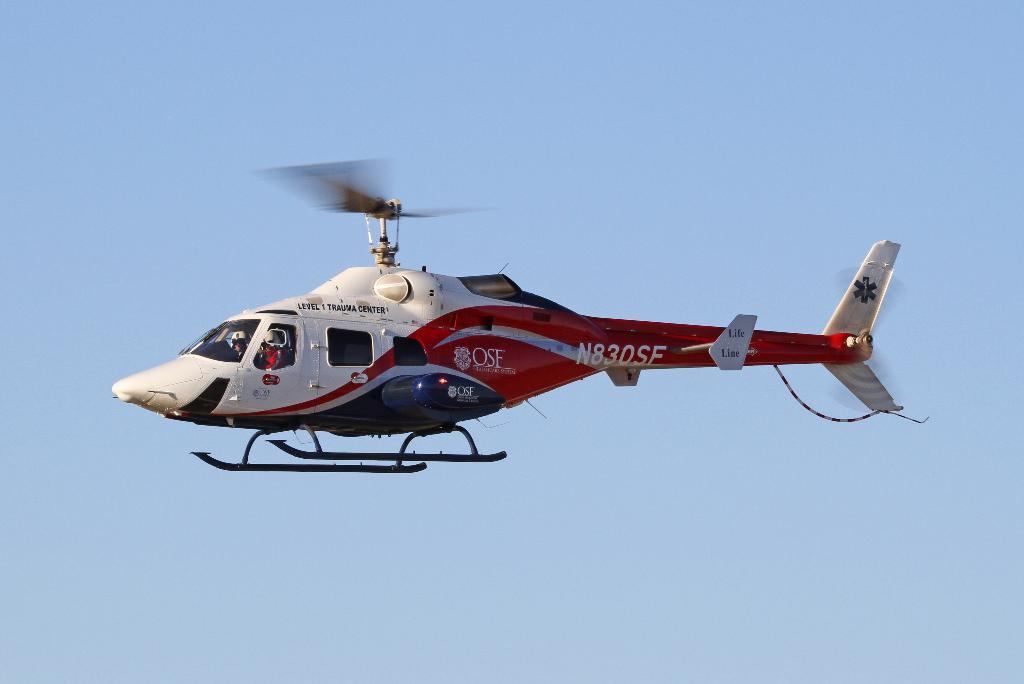What is the main subject of the picture? The main subject of the picture is a helicopter. What colors can be seen on the helicopter? The helicopter is white and red in color. What is the helicopter doing in the image? The helicopter is flying in the sky. What can be seen in the background of the image? The sky is visible in the background of the image. What is the color of the sky in the image? The sky is blue in color. How many quarters can be seen in the image? There are no quarters present in the image. Is there a bone visible in the image? There is no bone present in the image. 